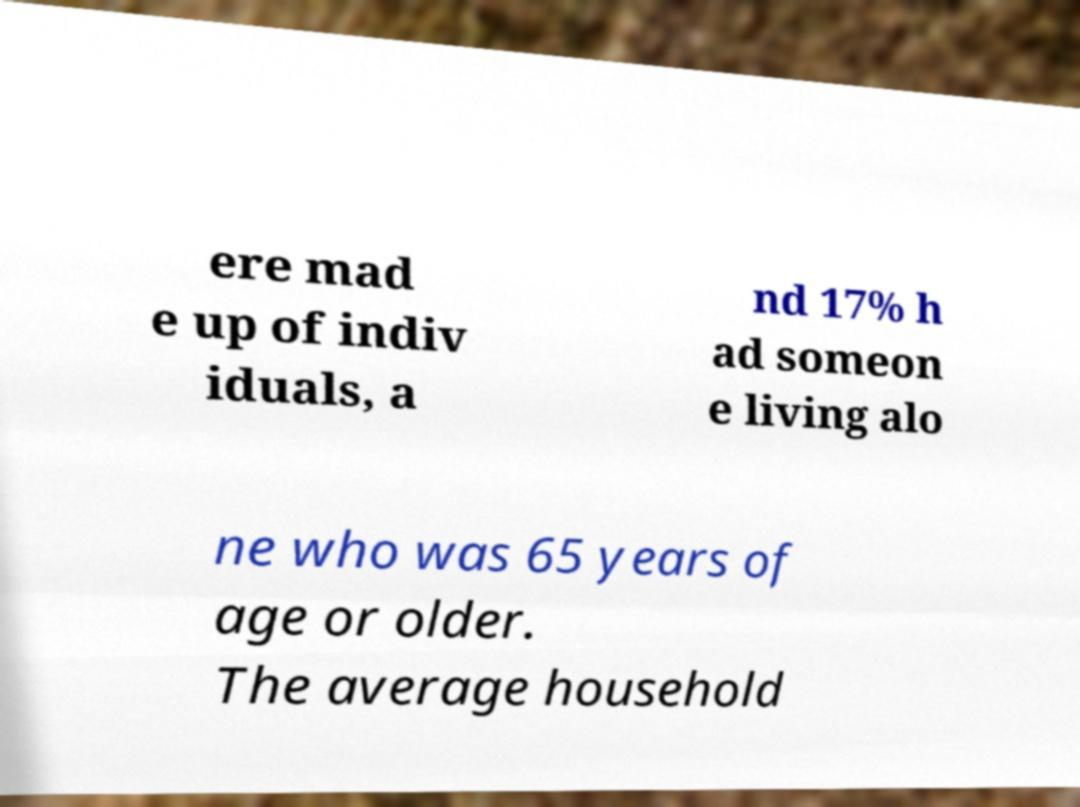Can you read and provide the text displayed in the image?This photo seems to have some interesting text. Can you extract and type it out for me? ere mad e up of indiv iduals, a nd 17% h ad someon e living alo ne who was 65 years of age or older. The average household 